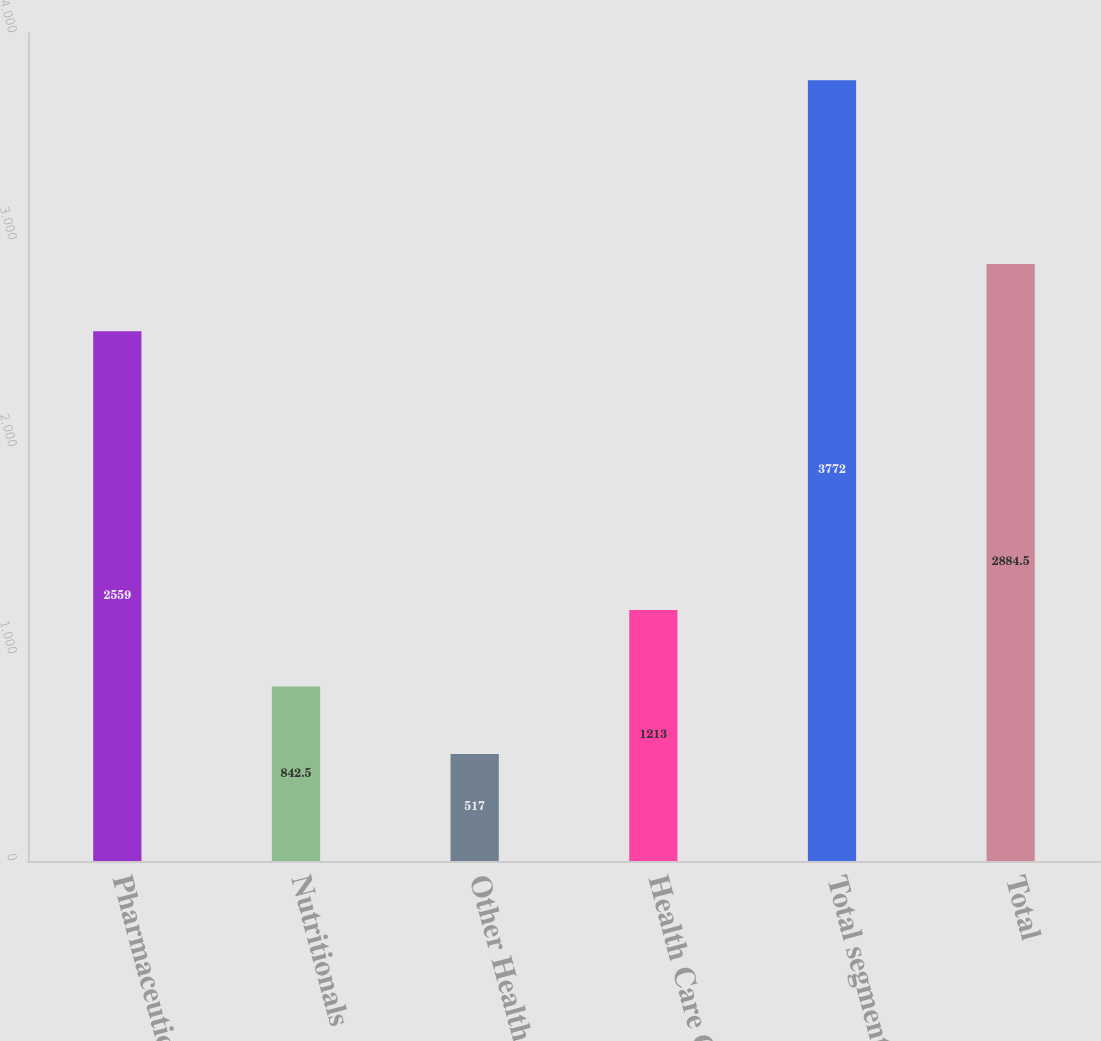<chart> <loc_0><loc_0><loc_500><loc_500><bar_chart><fcel>Pharmaceuticals<fcel>Nutritionals<fcel>Other Health Care<fcel>Health Care Group<fcel>Total segments<fcel>Total<nl><fcel>2559<fcel>842.5<fcel>517<fcel>1213<fcel>3772<fcel>2884.5<nl></chart> 